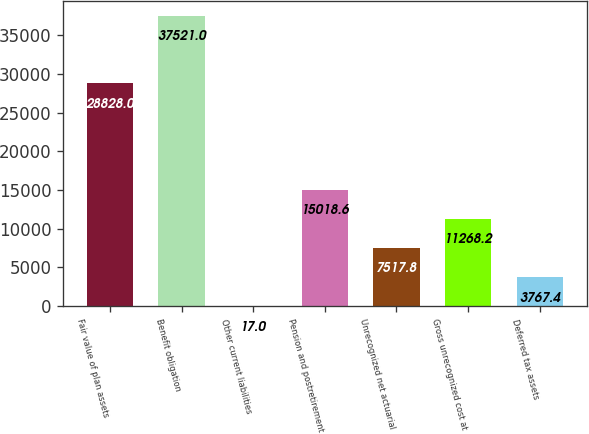Convert chart to OTSL. <chart><loc_0><loc_0><loc_500><loc_500><bar_chart><fcel>Fair value of plan assets<fcel>Benefit obligation<fcel>Other current liabilities<fcel>Pension and postretirement<fcel>Unrecognized net actuarial<fcel>Gross unrecognized cost at<fcel>Deferred tax assets<nl><fcel>28828<fcel>37521<fcel>17<fcel>15018.6<fcel>7517.8<fcel>11268.2<fcel>3767.4<nl></chart> 